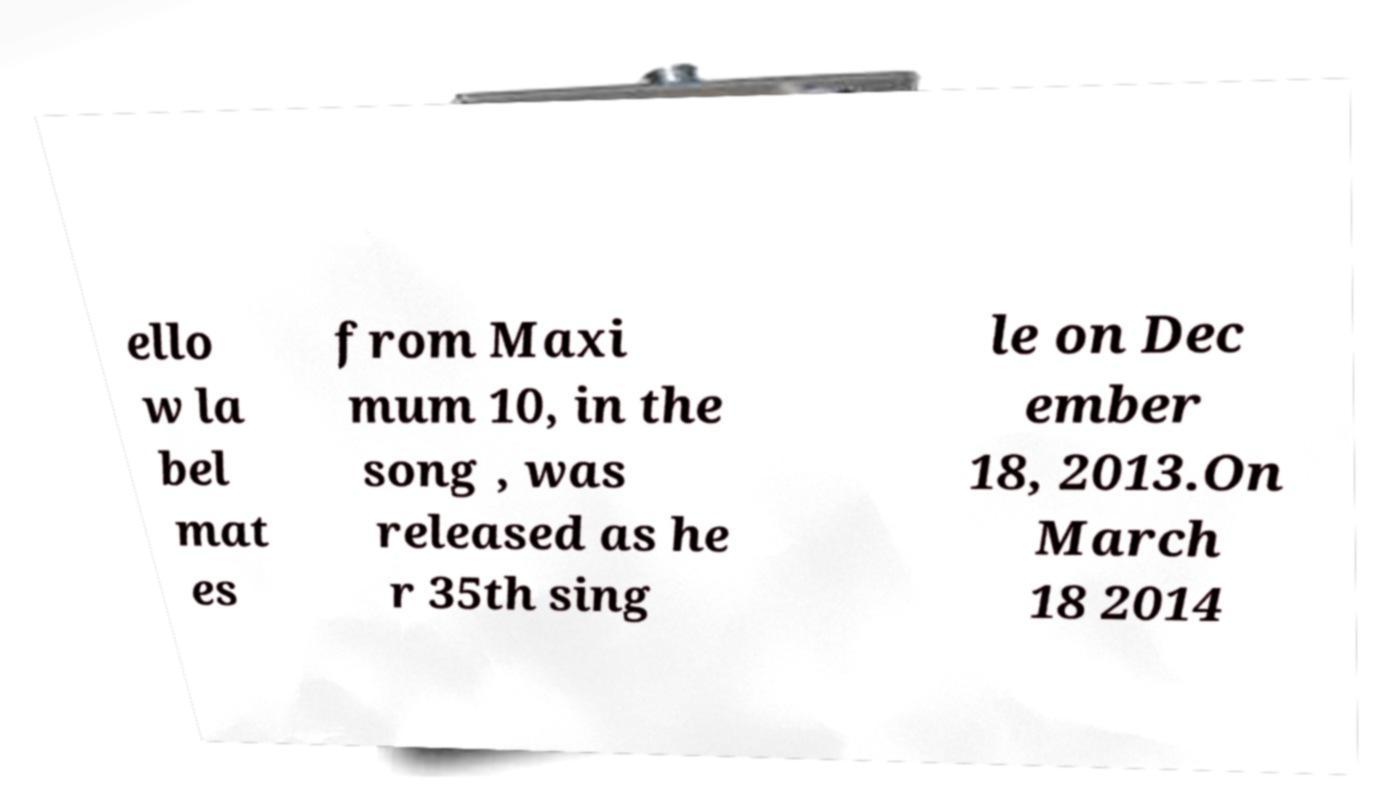What messages or text are displayed in this image? I need them in a readable, typed format. ello w la bel mat es from Maxi mum 10, in the song , was released as he r 35th sing le on Dec ember 18, 2013.On March 18 2014 